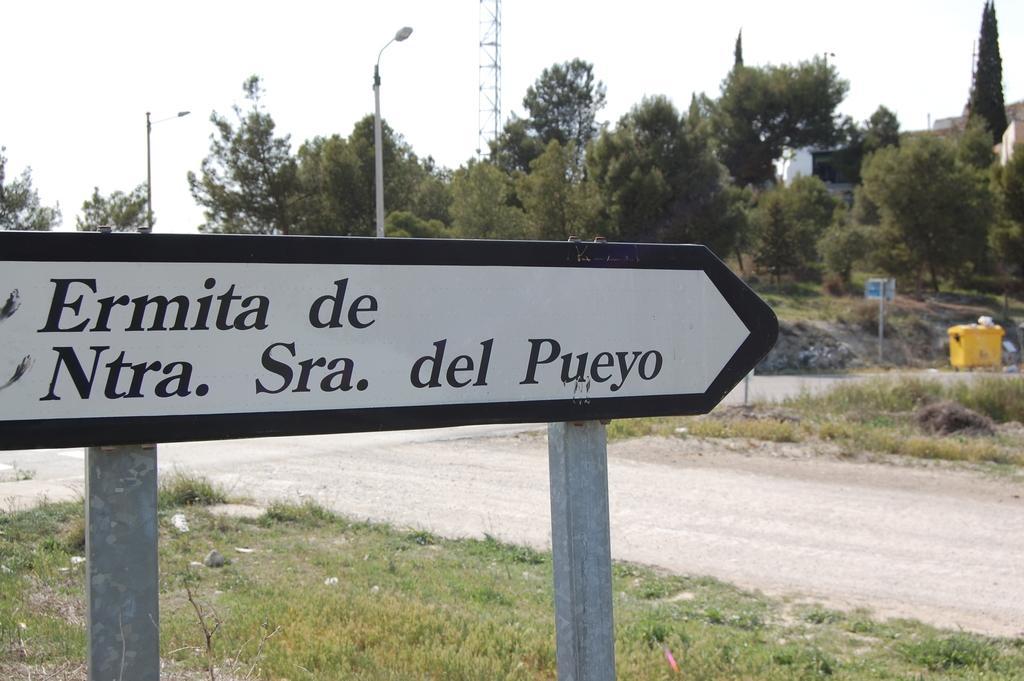Can you describe this image briefly? In this image there is the sky, there is a tower truncated towards the top of the image, there is a building truncated towards the right of the image, there are trees, there is a tree truncated towards the left of the image, there is a tree truncated towards the right of the image, there are poles, there are street lights, there is road, there is the grass, there is a board truncated towards the left of the image, there is text on the board, there is grass truncated towards the bottom of the image. 